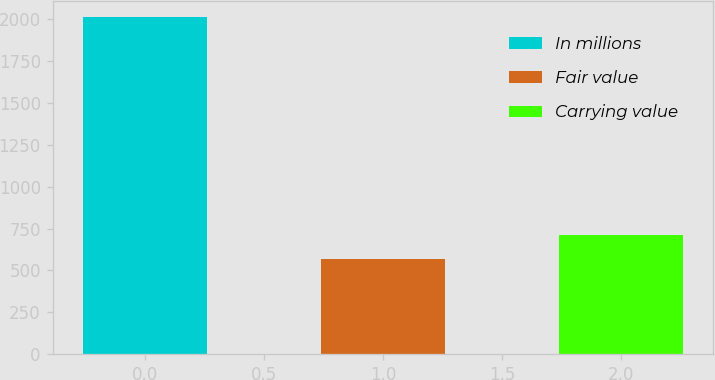Convert chart. <chart><loc_0><loc_0><loc_500><loc_500><bar_chart><fcel>In millions<fcel>Fair value<fcel>Carrying value<nl><fcel>2008<fcel>567<fcel>711.1<nl></chart> 